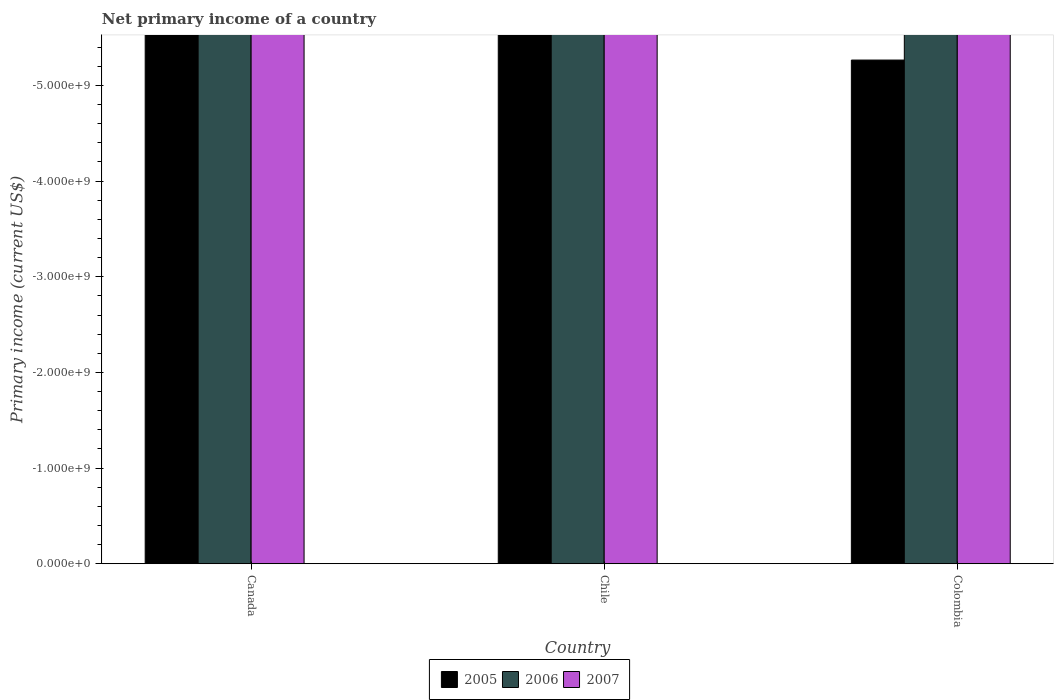How many different coloured bars are there?
Your answer should be compact. 0. Are the number of bars per tick equal to the number of legend labels?
Your answer should be very brief. No. How many bars are there on the 2nd tick from the left?
Keep it short and to the point. 0. How many bars are there on the 2nd tick from the right?
Offer a very short reply. 0. What is the label of the 1st group of bars from the left?
Offer a very short reply. Canada. In how many cases, is the number of bars for a given country not equal to the number of legend labels?
Offer a very short reply. 3. What is the average primary income in 2007 per country?
Keep it short and to the point. 0. In how many countries, is the primary income in 2007 greater than the average primary income in 2007 taken over all countries?
Offer a very short reply. 0. Is it the case that in every country, the sum of the primary income in 2005 and primary income in 2006 is greater than the primary income in 2007?
Provide a short and direct response. No. Are all the bars in the graph horizontal?
Your answer should be very brief. No. How many countries are there in the graph?
Offer a very short reply. 3. What is the difference between two consecutive major ticks on the Y-axis?
Your response must be concise. 1.00e+09. Are the values on the major ticks of Y-axis written in scientific E-notation?
Keep it short and to the point. Yes. Does the graph contain grids?
Give a very brief answer. No. How many legend labels are there?
Make the answer very short. 3. How are the legend labels stacked?
Keep it short and to the point. Horizontal. What is the title of the graph?
Your response must be concise. Net primary income of a country. Does "2007" appear as one of the legend labels in the graph?
Provide a succinct answer. Yes. What is the label or title of the X-axis?
Provide a succinct answer. Country. What is the label or title of the Y-axis?
Your response must be concise. Primary income (current US$). What is the Primary income (current US$) of 2007 in Canada?
Your response must be concise. 0. What is the Primary income (current US$) in 2005 in Colombia?
Your answer should be very brief. 0. What is the Primary income (current US$) in 2006 in Colombia?
Make the answer very short. 0. What is the Primary income (current US$) in 2007 in Colombia?
Your answer should be compact. 0. What is the total Primary income (current US$) in 2007 in the graph?
Provide a short and direct response. 0. What is the average Primary income (current US$) in 2005 per country?
Offer a terse response. 0. What is the average Primary income (current US$) in 2006 per country?
Offer a terse response. 0. 